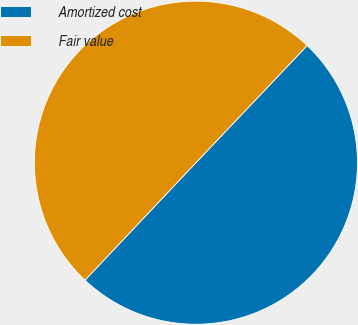<chart> <loc_0><loc_0><loc_500><loc_500><pie_chart><fcel>Amortized cost<fcel>Fair value<nl><fcel>49.95%<fcel>50.05%<nl></chart> 